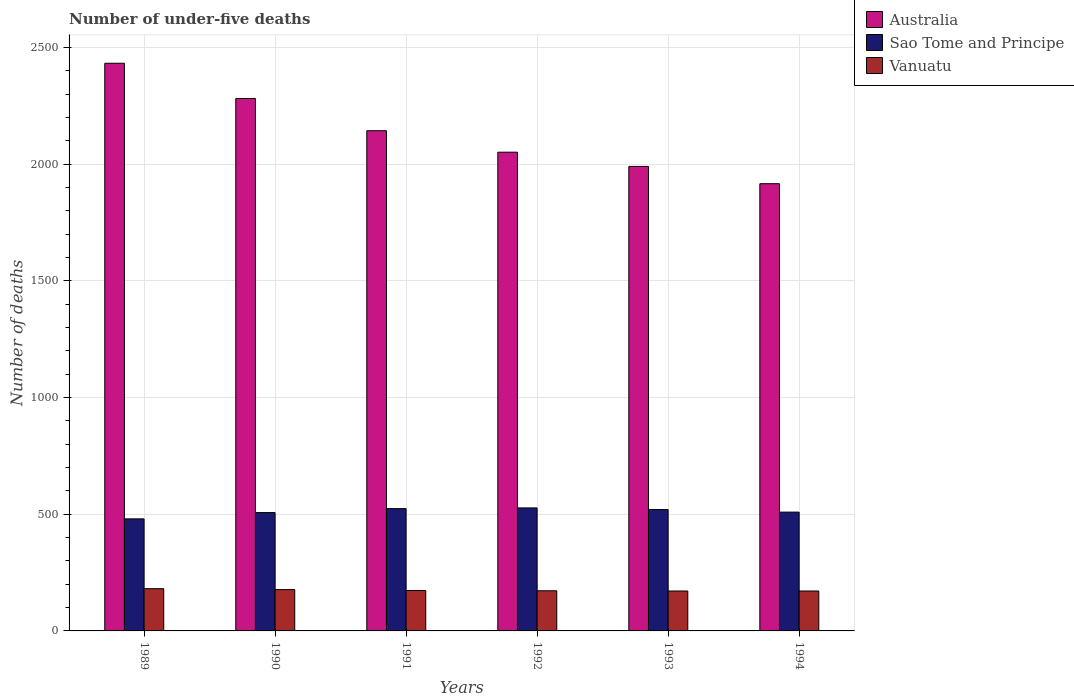How many groups of bars are there?
Offer a terse response. 6. How many bars are there on the 3rd tick from the left?
Keep it short and to the point. 3. In how many cases, is the number of bars for a given year not equal to the number of legend labels?
Provide a succinct answer. 0. What is the number of under-five deaths in Sao Tome and Principe in 1989?
Provide a succinct answer. 480. Across all years, what is the maximum number of under-five deaths in Sao Tome and Principe?
Your response must be concise. 527. Across all years, what is the minimum number of under-five deaths in Australia?
Provide a short and direct response. 1916. In which year was the number of under-five deaths in Vanuatu minimum?
Provide a succinct answer. 1993. What is the total number of under-five deaths in Vanuatu in the graph?
Your response must be concise. 1045. What is the difference between the number of under-five deaths in Vanuatu in 1989 and that in 1991?
Provide a succinct answer. 8. What is the difference between the number of under-five deaths in Vanuatu in 1989 and the number of under-five deaths in Sao Tome and Principe in 1994?
Keep it short and to the point. -328. What is the average number of under-five deaths in Australia per year?
Make the answer very short. 2135.5. In the year 1992, what is the difference between the number of under-five deaths in Australia and number of under-five deaths in Sao Tome and Principe?
Make the answer very short. 1524. In how many years, is the number of under-five deaths in Vanuatu greater than 2300?
Offer a very short reply. 0. What is the ratio of the number of under-five deaths in Vanuatu in 1990 to that in 1992?
Offer a very short reply. 1.03. Is the number of under-five deaths in Sao Tome and Principe in 1991 less than that in 1993?
Offer a very short reply. No. Is the difference between the number of under-five deaths in Australia in 1990 and 1991 greater than the difference between the number of under-five deaths in Sao Tome and Principe in 1990 and 1991?
Make the answer very short. Yes. What is the difference between the highest and the second highest number of under-five deaths in Sao Tome and Principe?
Keep it short and to the point. 3. In how many years, is the number of under-five deaths in Australia greater than the average number of under-five deaths in Australia taken over all years?
Your answer should be very brief. 3. Is it the case that in every year, the sum of the number of under-five deaths in Australia and number of under-five deaths in Vanuatu is greater than the number of under-five deaths in Sao Tome and Principe?
Give a very brief answer. Yes. Are the values on the major ticks of Y-axis written in scientific E-notation?
Ensure brevity in your answer.  No. Does the graph contain any zero values?
Provide a succinct answer. No. Does the graph contain grids?
Your response must be concise. Yes. Where does the legend appear in the graph?
Your response must be concise. Top right. How many legend labels are there?
Offer a very short reply. 3. How are the legend labels stacked?
Offer a terse response. Vertical. What is the title of the graph?
Provide a succinct answer. Number of under-five deaths. What is the label or title of the X-axis?
Offer a terse response. Years. What is the label or title of the Y-axis?
Keep it short and to the point. Number of deaths. What is the Number of deaths in Australia in 1989?
Offer a very short reply. 2432. What is the Number of deaths in Sao Tome and Principe in 1989?
Your answer should be very brief. 480. What is the Number of deaths of Vanuatu in 1989?
Your answer should be compact. 181. What is the Number of deaths of Australia in 1990?
Your response must be concise. 2281. What is the Number of deaths in Sao Tome and Principe in 1990?
Offer a terse response. 507. What is the Number of deaths in Vanuatu in 1990?
Provide a short and direct response. 177. What is the Number of deaths in Australia in 1991?
Keep it short and to the point. 2143. What is the Number of deaths of Sao Tome and Principe in 1991?
Make the answer very short. 524. What is the Number of deaths in Vanuatu in 1991?
Your response must be concise. 173. What is the Number of deaths of Australia in 1992?
Your answer should be compact. 2051. What is the Number of deaths of Sao Tome and Principe in 1992?
Ensure brevity in your answer.  527. What is the Number of deaths of Vanuatu in 1992?
Your answer should be very brief. 172. What is the Number of deaths in Australia in 1993?
Give a very brief answer. 1990. What is the Number of deaths of Sao Tome and Principe in 1993?
Make the answer very short. 520. What is the Number of deaths of Vanuatu in 1993?
Your response must be concise. 171. What is the Number of deaths of Australia in 1994?
Provide a short and direct response. 1916. What is the Number of deaths in Sao Tome and Principe in 1994?
Provide a succinct answer. 509. What is the Number of deaths of Vanuatu in 1994?
Offer a terse response. 171. Across all years, what is the maximum Number of deaths of Australia?
Give a very brief answer. 2432. Across all years, what is the maximum Number of deaths of Sao Tome and Principe?
Your response must be concise. 527. Across all years, what is the maximum Number of deaths in Vanuatu?
Your answer should be compact. 181. Across all years, what is the minimum Number of deaths in Australia?
Make the answer very short. 1916. Across all years, what is the minimum Number of deaths of Sao Tome and Principe?
Keep it short and to the point. 480. Across all years, what is the minimum Number of deaths in Vanuatu?
Give a very brief answer. 171. What is the total Number of deaths of Australia in the graph?
Provide a short and direct response. 1.28e+04. What is the total Number of deaths of Sao Tome and Principe in the graph?
Keep it short and to the point. 3067. What is the total Number of deaths of Vanuatu in the graph?
Your answer should be very brief. 1045. What is the difference between the Number of deaths of Australia in 1989 and that in 1990?
Your answer should be very brief. 151. What is the difference between the Number of deaths in Sao Tome and Principe in 1989 and that in 1990?
Keep it short and to the point. -27. What is the difference between the Number of deaths of Australia in 1989 and that in 1991?
Provide a short and direct response. 289. What is the difference between the Number of deaths of Sao Tome and Principe in 1989 and that in 1991?
Your response must be concise. -44. What is the difference between the Number of deaths of Vanuatu in 1989 and that in 1991?
Make the answer very short. 8. What is the difference between the Number of deaths of Australia in 1989 and that in 1992?
Your answer should be very brief. 381. What is the difference between the Number of deaths in Sao Tome and Principe in 1989 and that in 1992?
Provide a short and direct response. -47. What is the difference between the Number of deaths of Australia in 1989 and that in 1993?
Keep it short and to the point. 442. What is the difference between the Number of deaths of Sao Tome and Principe in 1989 and that in 1993?
Give a very brief answer. -40. What is the difference between the Number of deaths in Australia in 1989 and that in 1994?
Make the answer very short. 516. What is the difference between the Number of deaths in Australia in 1990 and that in 1991?
Provide a succinct answer. 138. What is the difference between the Number of deaths of Sao Tome and Principe in 1990 and that in 1991?
Keep it short and to the point. -17. What is the difference between the Number of deaths in Australia in 1990 and that in 1992?
Provide a succinct answer. 230. What is the difference between the Number of deaths in Vanuatu in 1990 and that in 1992?
Your response must be concise. 5. What is the difference between the Number of deaths in Australia in 1990 and that in 1993?
Provide a succinct answer. 291. What is the difference between the Number of deaths of Australia in 1990 and that in 1994?
Ensure brevity in your answer.  365. What is the difference between the Number of deaths in Sao Tome and Principe in 1990 and that in 1994?
Offer a very short reply. -2. What is the difference between the Number of deaths of Vanuatu in 1990 and that in 1994?
Your answer should be very brief. 6. What is the difference between the Number of deaths of Australia in 1991 and that in 1992?
Your answer should be very brief. 92. What is the difference between the Number of deaths in Sao Tome and Principe in 1991 and that in 1992?
Your answer should be compact. -3. What is the difference between the Number of deaths in Australia in 1991 and that in 1993?
Ensure brevity in your answer.  153. What is the difference between the Number of deaths of Sao Tome and Principe in 1991 and that in 1993?
Make the answer very short. 4. What is the difference between the Number of deaths of Vanuatu in 1991 and that in 1993?
Provide a short and direct response. 2. What is the difference between the Number of deaths of Australia in 1991 and that in 1994?
Ensure brevity in your answer.  227. What is the difference between the Number of deaths of Sao Tome and Principe in 1991 and that in 1994?
Give a very brief answer. 15. What is the difference between the Number of deaths of Vanuatu in 1991 and that in 1994?
Keep it short and to the point. 2. What is the difference between the Number of deaths of Australia in 1992 and that in 1993?
Ensure brevity in your answer.  61. What is the difference between the Number of deaths in Sao Tome and Principe in 1992 and that in 1993?
Ensure brevity in your answer.  7. What is the difference between the Number of deaths of Vanuatu in 1992 and that in 1993?
Your answer should be very brief. 1. What is the difference between the Number of deaths of Australia in 1992 and that in 1994?
Ensure brevity in your answer.  135. What is the difference between the Number of deaths of Australia in 1989 and the Number of deaths of Sao Tome and Principe in 1990?
Offer a terse response. 1925. What is the difference between the Number of deaths in Australia in 1989 and the Number of deaths in Vanuatu in 1990?
Your response must be concise. 2255. What is the difference between the Number of deaths of Sao Tome and Principe in 1989 and the Number of deaths of Vanuatu in 1990?
Give a very brief answer. 303. What is the difference between the Number of deaths in Australia in 1989 and the Number of deaths in Sao Tome and Principe in 1991?
Ensure brevity in your answer.  1908. What is the difference between the Number of deaths of Australia in 1989 and the Number of deaths of Vanuatu in 1991?
Give a very brief answer. 2259. What is the difference between the Number of deaths in Sao Tome and Principe in 1989 and the Number of deaths in Vanuatu in 1991?
Make the answer very short. 307. What is the difference between the Number of deaths of Australia in 1989 and the Number of deaths of Sao Tome and Principe in 1992?
Provide a short and direct response. 1905. What is the difference between the Number of deaths in Australia in 1989 and the Number of deaths in Vanuatu in 1992?
Ensure brevity in your answer.  2260. What is the difference between the Number of deaths of Sao Tome and Principe in 1989 and the Number of deaths of Vanuatu in 1992?
Offer a very short reply. 308. What is the difference between the Number of deaths of Australia in 1989 and the Number of deaths of Sao Tome and Principe in 1993?
Your response must be concise. 1912. What is the difference between the Number of deaths in Australia in 1989 and the Number of deaths in Vanuatu in 1993?
Your answer should be very brief. 2261. What is the difference between the Number of deaths in Sao Tome and Principe in 1989 and the Number of deaths in Vanuatu in 1993?
Offer a very short reply. 309. What is the difference between the Number of deaths in Australia in 1989 and the Number of deaths in Sao Tome and Principe in 1994?
Your response must be concise. 1923. What is the difference between the Number of deaths of Australia in 1989 and the Number of deaths of Vanuatu in 1994?
Your response must be concise. 2261. What is the difference between the Number of deaths of Sao Tome and Principe in 1989 and the Number of deaths of Vanuatu in 1994?
Your answer should be very brief. 309. What is the difference between the Number of deaths of Australia in 1990 and the Number of deaths of Sao Tome and Principe in 1991?
Make the answer very short. 1757. What is the difference between the Number of deaths of Australia in 1990 and the Number of deaths of Vanuatu in 1991?
Keep it short and to the point. 2108. What is the difference between the Number of deaths in Sao Tome and Principe in 1990 and the Number of deaths in Vanuatu in 1991?
Your answer should be very brief. 334. What is the difference between the Number of deaths of Australia in 1990 and the Number of deaths of Sao Tome and Principe in 1992?
Offer a very short reply. 1754. What is the difference between the Number of deaths in Australia in 1990 and the Number of deaths in Vanuatu in 1992?
Provide a succinct answer. 2109. What is the difference between the Number of deaths of Sao Tome and Principe in 1990 and the Number of deaths of Vanuatu in 1992?
Provide a short and direct response. 335. What is the difference between the Number of deaths of Australia in 1990 and the Number of deaths of Sao Tome and Principe in 1993?
Your answer should be very brief. 1761. What is the difference between the Number of deaths in Australia in 1990 and the Number of deaths in Vanuatu in 1993?
Ensure brevity in your answer.  2110. What is the difference between the Number of deaths of Sao Tome and Principe in 1990 and the Number of deaths of Vanuatu in 1993?
Offer a terse response. 336. What is the difference between the Number of deaths of Australia in 1990 and the Number of deaths of Sao Tome and Principe in 1994?
Provide a short and direct response. 1772. What is the difference between the Number of deaths of Australia in 1990 and the Number of deaths of Vanuatu in 1994?
Offer a very short reply. 2110. What is the difference between the Number of deaths of Sao Tome and Principe in 1990 and the Number of deaths of Vanuatu in 1994?
Your answer should be compact. 336. What is the difference between the Number of deaths in Australia in 1991 and the Number of deaths in Sao Tome and Principe in 1992?
Give a very brief answer. 1616. What is the difference between the Number of deaths in Australia in 1991 and the Number of deaths in Vanuatu in 1992?
Make the answer very short. 1971. What is the difference between the Number of deaths in Sao Tome and Principe in 1991 and the Number of deaths in Vanuatu in 1992?
Your response must be concise. 352. What is the difference between the Number of deaths of Australia in 1991 and the Number of deaths of Sao Tome and Principe in 1993?
Your answer should be compact. 1623. What is the difference between the Number of deaths of Australia in 1991 and the Number of deaths of Vanuatu in 1993?
Give a very brief answer. 1972. What is the difference between the Number of deaths of Sao Tome and Principe in 1991 and the Number of deaths of Vanuatu in 1993?
Provide a short and direct response. 353. What is the difference between the Number of deaths in Australia in 1991 and the Number of deaths in Sao Tome and Principe in 1994?
Provide a short and direct response. 1634. What is the difference between the Number of deaths of Australia in 1991 and the Number of deaths of Vanuatu in 1994?
Keep it short and to the point. 1972. What is the difference between the Number of deaths in Sao Tome and Principe in 1991 and the Number of deaths in Vanuatu in 1994?
Your answer should be very brief. 353. What is the difference between the Number of deaths of Australia in 1992 and the Number of deaths of Sao Tome and Principe in 1993?
Ensure brevity in your answer.  1531. What is the difference between the Number of deaths of Australia in 1992 and the Number of deaths of Vanuatu in 1993?
Make the answer very short. 1880. What is the difference between the Number of deaths in Sao Tome and Principe in 1992 and the Number of deaths in Vanuatu in 1993?
Keep it short and to the point. 356. What is the difference between the Number of deaths in Australia in 1992 and the Number of deaths in Sao Tome and Principe in 1994?
Your answer should be very brief. 1542. What is the difference between the Number of deaths in Australia in 1992 and the Number of deaths in Vanuatu in 1994?
Your answer should be very brief. 1880. What is the difference between the Number of deaths of Sao Tome and Principe in 1992 and the Number of deaths of Vanuatu in 1994?
Give a very brief answer. 356. What is the difference between the Number of deaths in Australia in 1993 and the Number of deaths in Sao Tome and Principe in 1994?
Offer a very short reply. 1481. What is the difference between the Number of deaths of Australia in 1993 and the Number of deaths of Vanuatu in 1994?
Keep it short and to the point. 1819. What is the difference between the Number of deaths in Sao Tome and Principe in 1993 and the Number of deaths in Vanuatu in 1994?
Offer a very short reply. 349. What is the average Number of deaths in Australia per year?
Ensure brevity in your answer.  2135.5. What is the average Number of deaths of Sao Tome and Principe per year?
Provide a short and direct response. 511.17. What is the average Number of deaths in Vanuatu per year?
Your answer should be compact. 174.17. In the year 1989, what is the difference between the Number of deaths in Australia and Number of deaths in Sao Tome and Principe?
Make the answer very short. 1952. In the year 1989, what is the difference between the Number of deaths in Australia and Number of deaths in Vanuatu?
Keep it short and to the point. 2251. In the year 1989, what is the difference between the Number of deaths of Sao Tome and Principe and Number of deaths of Vanuatu?
Keep it short and to the point. 299. In the year 1990, what is the difference between the Number of deaths of Australia and Number of deaths of Sao Tome and Principe?
Provide a short and direct response. 1774. In the year 1990, what is the difference between the Number of deaths in Australia and Number of deaths in Vanuatu?
Provide a succinct answer. 2104. In the year 1990, what is the difference between the Number of deaths in Sao Tome and Principe and Number of deaths in Vanuatu?
Make the answer very short. 330. In the year 1991, what is the difference between the Number of deaths in Australia and Number of deaths in Sao Tome and Principe?
Your answer should be compact. 1619. In the year 1991, what is the difference between the Number of deaths in Australia and Number of deaths in Vanuatu?
Your response must be concise. 1970. In the year 1991, what is the difference between the Number of deaths in Sao Tome and Principe and Number of deaths in Vanuatu?
Provide a short and direct response. 351. In the year 1992, what is the difference between the Number of deaths in Australia and Number of deaths in Sao Tome and Principe?
Your answer should be very brief. 1524. In the year 1992, what is the difference between the Number of deaths of Australia and Number of deaths of Vanuatu?
Your answer should be compact. 1879. In the year 1992, what is the difference between the Number of deaths of Sao Tome and Principe and Number of deaths of Vanuatu?
Keep it short and to the point. 355. In the year 1993, what is the difference between the Number of deaths of Australia and Number of deaths of Sao Tome and Principe?
Offer a terse response. 1470. In the year 1993, what is the difference between the Number of deaths of Australia and Number of deaths of Vanuatu?
Ensure brevity in your answer.  1819. In the year 1993, what is the difference between the Number of deaths in Sao Tome and Principe and Number of deaths in Vanuatu?
Make the answer very short. 349. In the year 1994, what is the difference between the Number of deaths of Australia and Number of deaths of Sao Tome and Principe?
Offer a terse response. 1407. In the year 1994, what is the difference between the Number of deaths of Australia and Number of deaths of Vanuatu?
Ensure brevity in your answer.  1745. In the year 1994, what is the difference between the Number of deaths of Sao Tome and Principe and Number of deaths of Vanuatu?
Your answer should be very brief. 338. What is the ratio of the Number of deaths in Australia in 1989 to that in 1990?
Offer a terse response. 1.07. What is the ratio of the Number of deaths in Sao Tome and Principe in 1989 to that in 1990?
Ensure brevity in your answer.  0.95. What is the ratio of the Number of deaths in Vanuatu in 1989 to that in 1990?
Ensure brevity in your answer.  1.02. What is the ratio of the Number of deaths of Australia in 1989 to that in 1991?
Provide a short and direct response. 1.13. What is the ratio of the Number of deaths in Sao Tome and Principe in 1989 to that in 1991?
Give a very brief answer. 0.92. What is the ratio of the Number of deaths of Vanuatu in 1989 to that in 1991?
Offer a very short reply. 1.05. What is the ratio of the Number of deaths of Australia in 1989 to that in 1992?
Offer a very short reply. 1.19. What is the ratio of the Number of deaths in Sao Tome and Principe in 1989 to that in 1992?
Keep it short and to the point. 0.91. What is the ratio of the Number of deaths of Vanuatu in 1989 to that in 1992?
Offer a terse response. 1.05. What is the ratio of the Number of deaths in Australia in 1989 to that in 1993?
Keep it short and to the point. 1.22. What is the ratio of the Number of deaths in Sao Tome and Principe in 1989 to that in 1993?
Offer a terse response. 0.92. What is the ratio of the Number of deaths in Vanuatu in 1989 to that in 1993?
Provide a succinct answer. 1.06. What is the ratio of the Number of deaths in Australia in 1989 to that in 1994?
Make the answer very short. 1.27. What is the ratio of the Number of deaths in Sao Tome and Principe in 1989 to that in 1994?
Give a very brief answer. 0.94. What is the ratio of the Number of deaths in Vanuatu in 1989 to that in 1994?
Ensure brevity in your answer.  1.06. What is the ratio of the Number of deaths of Australia in 1990 to that in 1991?
Give a very brief answer. 1.06. What is the ratio of the Number of deaths in Sao Tome and Principe in 1990 to that in 1991?
Make the answer very short. 0.97. What is the ratio of the Number of deaths in Vanuatu in 1990 to that in 1991?
Provide a succinct answer. 1.02. What is the ratio of the Number of deaths in Australia in 1990 to that in 1992?
Keep it short and to the point. 1.11. What is the ratio of the Number of deaths in Vanuatu in 1990 to that in 1992?
Make the answer very short. 1.03. What is the ratio of the Number of deaths of Australia in 1990 to that in 1993?
Make the answer very short. 1.15. What is the ratio of the Number of deaths in Sao Tome and Principe in 1990 to that in 1993?
Your response must be concise. 0.97. What is the ratio of the Number of deaths of Vanuatu in 1990 to that in 1993?
Your answer should be very brief. 1.04. What is the ratio of the Number of deaths of Australia in 1990 to that in 1994?
Provide a succinct answer. 1.19. What is the ratio of the Number of deaths of Sao Tome and Principe in 1990 to that in 1994?
Your response must be concise. 1. What is the ratio of the Number of deaths of Vanuatu in 1990 to that in 1994?
Make the answer very short. 1.04. What is the ratio of the Number of deaths in Australia in 1991 to that in 1992?
Your response must be concise. 1.04. What is the ratio of the Number of deaths in Vanuatu in 1991 to that in 1992?
Offer a very short reply. 1.01. What is the ratio of the Number of deaths in Australia in 1991 to that in 1993?
Provide a short and direct response. 1.08. What is the ratio of the Number of deaths in Sao Tome and Principe in 1991 to that in 1993?
Keep it short and to the point. 1.01. What is the ratio of the Number of deaths of Vanuatu in 1991 to that in 1993?
Ensure brevity in your answer.  1.01. What is the ratio of the Number of deaths in Australia in 1991 to that in 1994?
Ensure brevity in your answer.  1.12. What is the ratio of the Number of deaths of Sao Tome and Principe in 1991 to that in 1994?
Your answer should be compact. 1.03. What is the ratio of the Number of deaths of Vanuatu in 1991 to that in 1994?
Provide a short and direct response. 1.01. What is the ratio of the Number of deaths in Australia in 1992 to that in 1993?
Ensure brevity in your answer.  1.03. What is the ratio of the Number of deaths of Sao Tome and Principe in 1992 to that in 1993?
Offer a very short reply. 1.01. What is the ratio of the Number of deaths in Australia in 1992 to that in 1994?
Keep it short and to the point. 1.07. What is the ratio of the Number of deaths in Sao Tome and Principe in 1992 to that in 1994?
Ensure brevity in your answer.  1.04. What is the ratio of the Number of deaths in Vanuatu in 1992 to that in 1994?
Your answer should be very brief. 1.01. What is the ratio of the Number of deaths of Australia in 1993 to that in 1994?
Offer a very short reply. 1.04. What is the ratio of the Number of deaths in Sao Tome and Principe in 1993 to that in 1994?
Offer a terse response. 1.02. What is the difference between the highest and the second highest Number of deaths of Australia?
Offer a very short reply. 151. What is the difference between the highest and the second highest Number of deaths of Sao Tome and Principe?
Provide a short and direct response. 3. What is the difference between the highest and the lowest Number of deaths of Australia?
Your answer should be very brief. 516. What is the difference between the highest and the lowest Number of deaths of Vanuatu?
Your response must be concise. 10. 